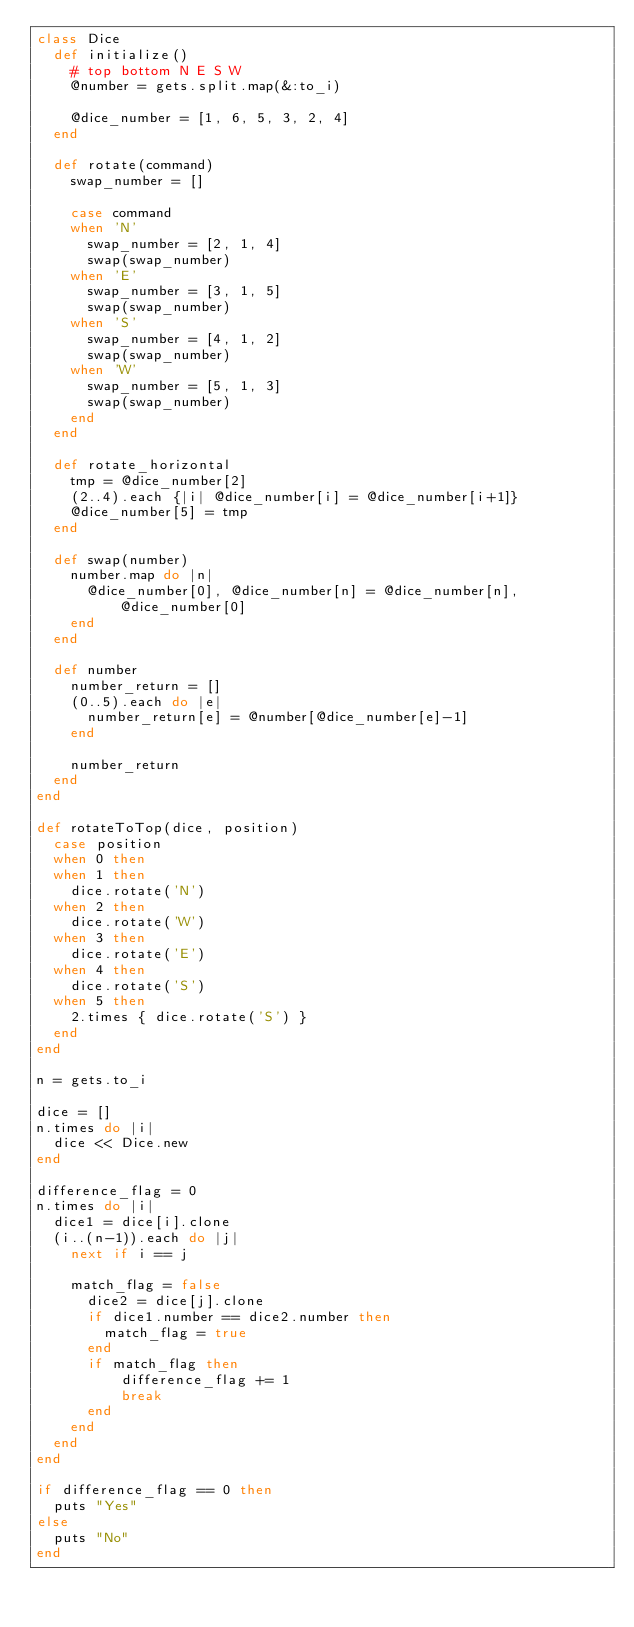<code> <loc_0><loc_0><loc_500><loc_500><_Ruby_>class Dice
	def initialize()
		# top bottom N E S W
		@number = gets.split.map(&:to_i)

		@dice_number = [1, 6, 5, 3, 2, 4]
	end

	def rotate(command)
		swap_number = []

		case command
		when 'N'
			swap_number = [2, 1, 4]
			swap(swap_number)
		when 'E'
			swap_number = [3, 1, 5]
			swap(swap_number)
		when 'S'
			swap_number = [4, 1, 2]
			swap(swap_number)
		when 'W'
			swap_number = [5, 1, 3]
			swap(swap_number)
		end
	end

	def rotate_horizontal
		tmp = @dice_number[2]
		(2..4).each {|i| @dice_number[i] = @dice_number[i+1]}
		@dice_number[5] = tmp
	end

	def swap(number)
		number.map do |n|
			@dice_number[0], @dice_number[n] = @dice_number[n], @dice_number[0]
		end
	end

	def number
		number_return = []
		(0..5).each do |e|
			number_return[e] = @number[@dice_number[e]-1]
		end
		
		number_return
	end
end

def rotateToTop(dice, position)
	case position
	when 0 then
	when 1 then
		dice.rotate('N')
	when 2 then
		dice.rotate('W')
	when 3 then
		dice.rotate('E')
	when 4 then
		dice.rotate('S')
	when 5 then
		2.times { dice.rotate('S') }
	end
end

n = gets.to_i

dice = []
n.times do |i|
	dice << Dice.new
end

difference_flag = 0
n.times do |i|
	dice1 = dice[i].clone
	(i..(n-1)).each do |j|
		next if i == j

		match_flag = false
			dice2 = dice[j].clone
			if dice1.number == dice2.number then
				match_flag = true
			end
			if match_flag then
					difference_flag += 1
					break
			end
		end
	end
end

if difference_flag == 0 then
	puts "Yes"
else
	puts "No"
end</code> 